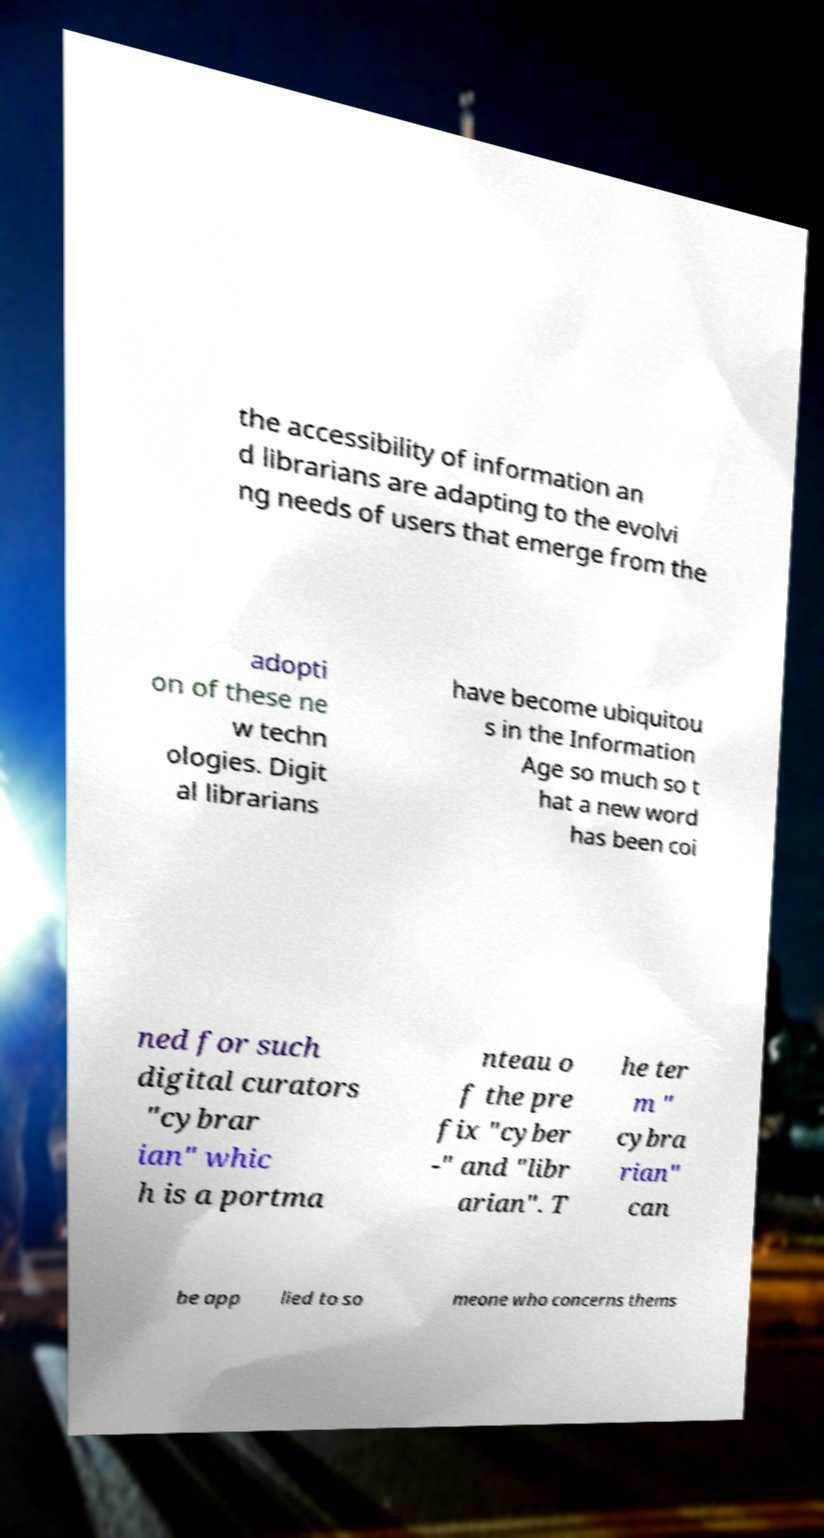Can you read and provide the text displayed in the image?This photo seems to have some interesting text. Can you extract and type it out for me? the accessibility of information an d librarians are adapting to the evolvi ng needs of users that emerge from the adopti on of these ne w techn ologies. Digit al librarians have become ubiquitou s in the Information Age so much so t hat a new word has been coi ned for such digital curators "cybrar ian" whic h is a portma nteau o f the pre fix "cyber -" and "libr arian". T he ter m " cybra rian" can be app lied to so meone who concerns thems 